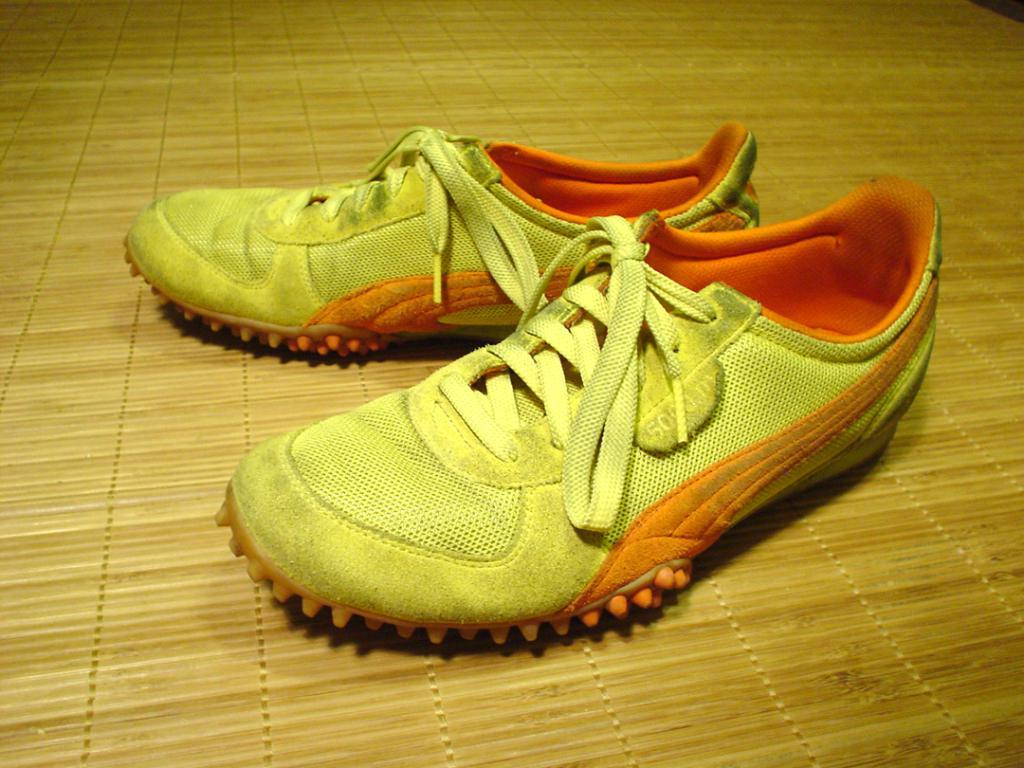What type of objects are present in the image? There are shoes in the image. Can you describe the colors of the shoes? The shoes are in white and orange color. Are there any bones visible on the seashore in the image? There is no seashore or bones present in the image; it only features shoes in white and orange color. 